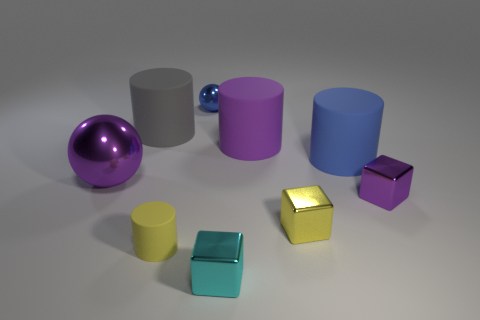Add 1 shiny objects. How many objects exist? 10 Subtract all cubes. How many objects are left? 6 Subtract 1 yellow blocks. How many objects are left? 8 Subtract all small gray matte cubes. Subtract all yellow objects. How many objects are left? 7 Add 1 large gray cylinders. How many large gray cylinders are left? 2 Add 7 tiny purple matte objects. How many tiny purple matte objects exist? 7 